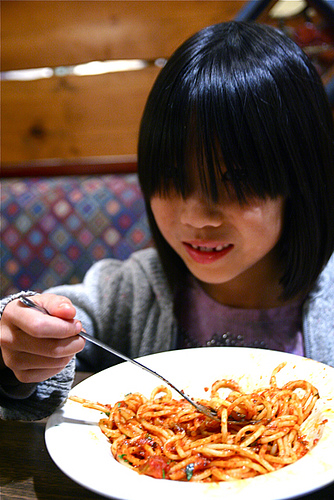<image>
Can you confirm if the girl is in front of the spaghetti? No. The girl is not in front of the spaghetti. The spatial positioning shows a different relationship between these objects. 